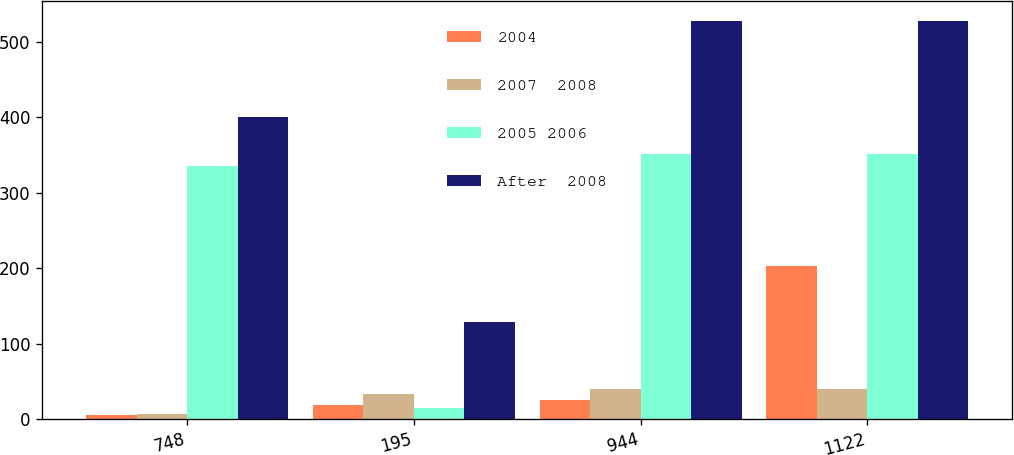<chart> <loc_0><loc_0><loc_500><loc_500><stacked_bar_chart><ecel><fcel>748<fcel>195<fcel>944<fcel>1122<nl><fcel>2004<fcel>5<fcel>19<fcel>25<fcel>203<nl><fcel>2007  2008<fcel>7<fcel>33<fcel>40<fcel>40<nl><fcel>2005 2006<fcel>336<fcel>15<fcel>351<fcel>351<nl><fcel>After  2008<fcel>400<fcel>128<fcel>528<fcel>528<nl></chart> 